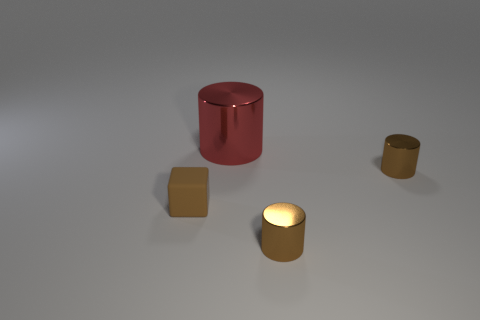Add 3 big metallic cylinders. How many objects exist? 7 Subtract all blocks. How many objects are left? 3 Add 4 blocks. How many blocks exist? 5 Subtract 0 blue blocks. How many objects are left? 4 Subtract all cylinders. Subtract all large red metal cylinders. How many objects are left? 0 Add 3 tiny brown matte things. How many tiny brown matte things are left? 4 